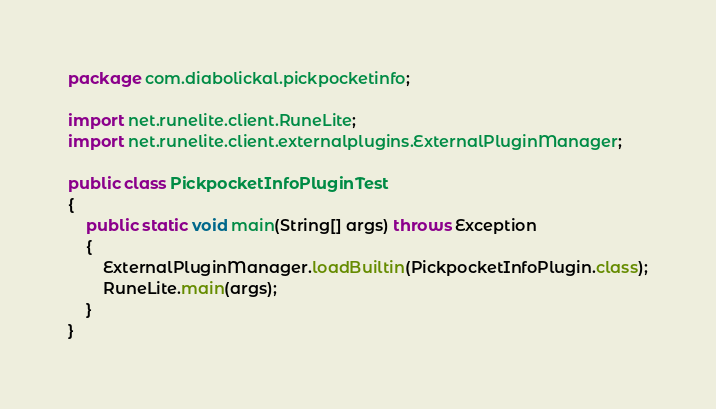Convert code to text. <code><loc_0><loc_0><loc_500><loc_500><_Java_>package com.diabolickal.pickpocketinfo;

import net.runelite.client.RuneLite;
import net.runelite.client.externalplugins.ExternalPluginManager;

public class PickpocketInfoPluginTest
{
	public static void main(String[] args) throws Exception
	{
		ExternalPluginManager.loadBuiltin(PickpocketInfoPlugin.class);
		RuneLite.main(args);
	}
}</code> 